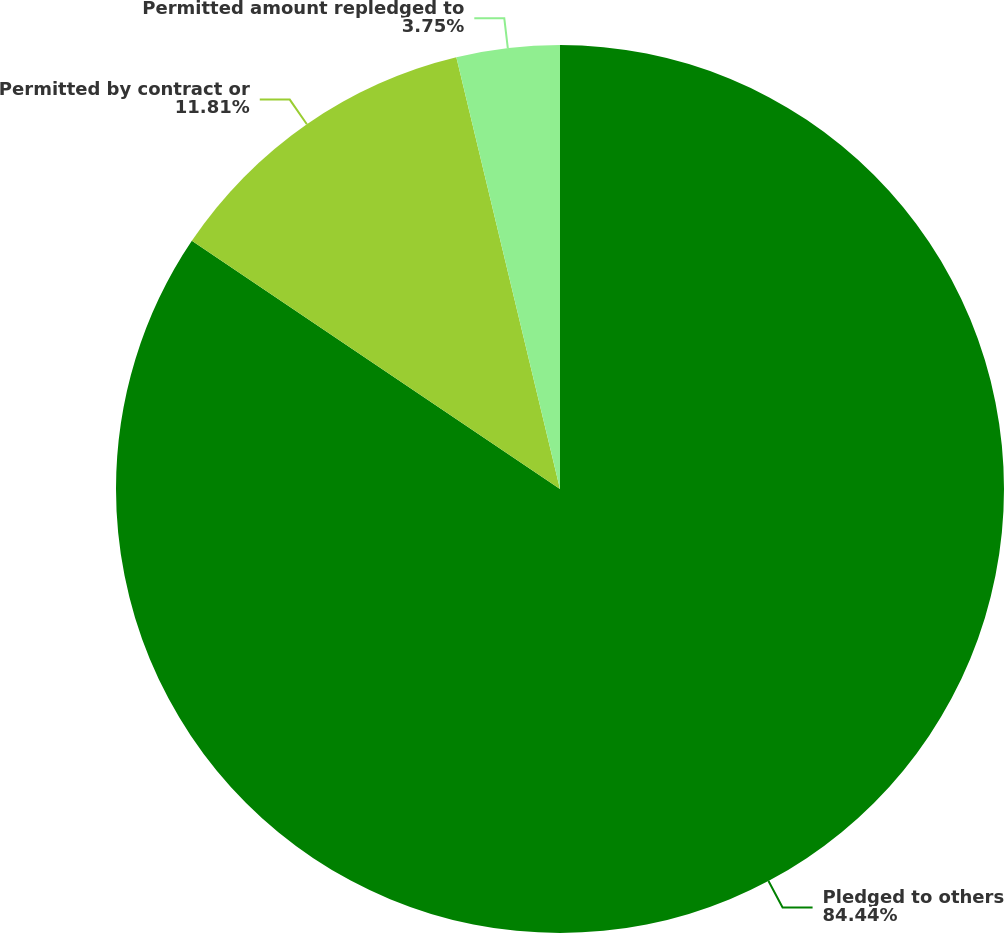Convert chart. <chart><loc_0><loc_0><loc_500><loc_500><pie_chart><fcel>Pledged to others<fcel>Permitted by contract or<fcel>Permitted amount repledged to<nl><fcel>84.44%<fcel>11.81%<fcel>3.75%<nl></chart> 